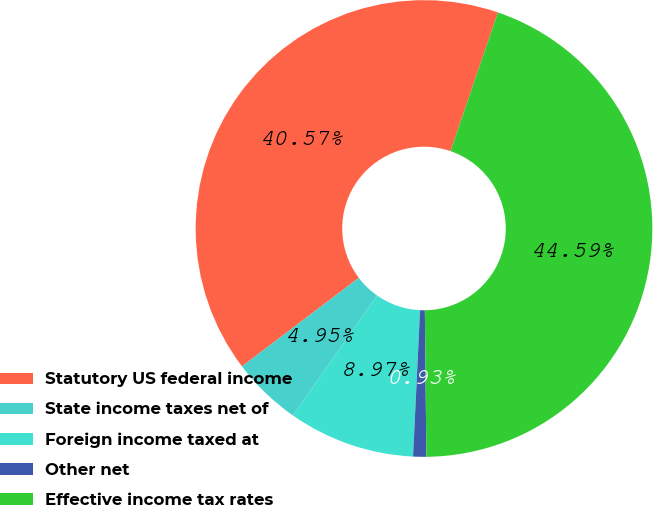<chart> <loc_0><loc_0><loc_500><loc_500><pie_chart><fcel>Statutory US federal income<fcel>State income taxes net of<fcel>Foreign income taxed at<fcel>Other net<fcel>Effective income tax rates<nl><fcel>40.57%<fcel>4.95%<fcel>8.97%<fcel>0.93%<fcel>44.59%<nl></chart> 